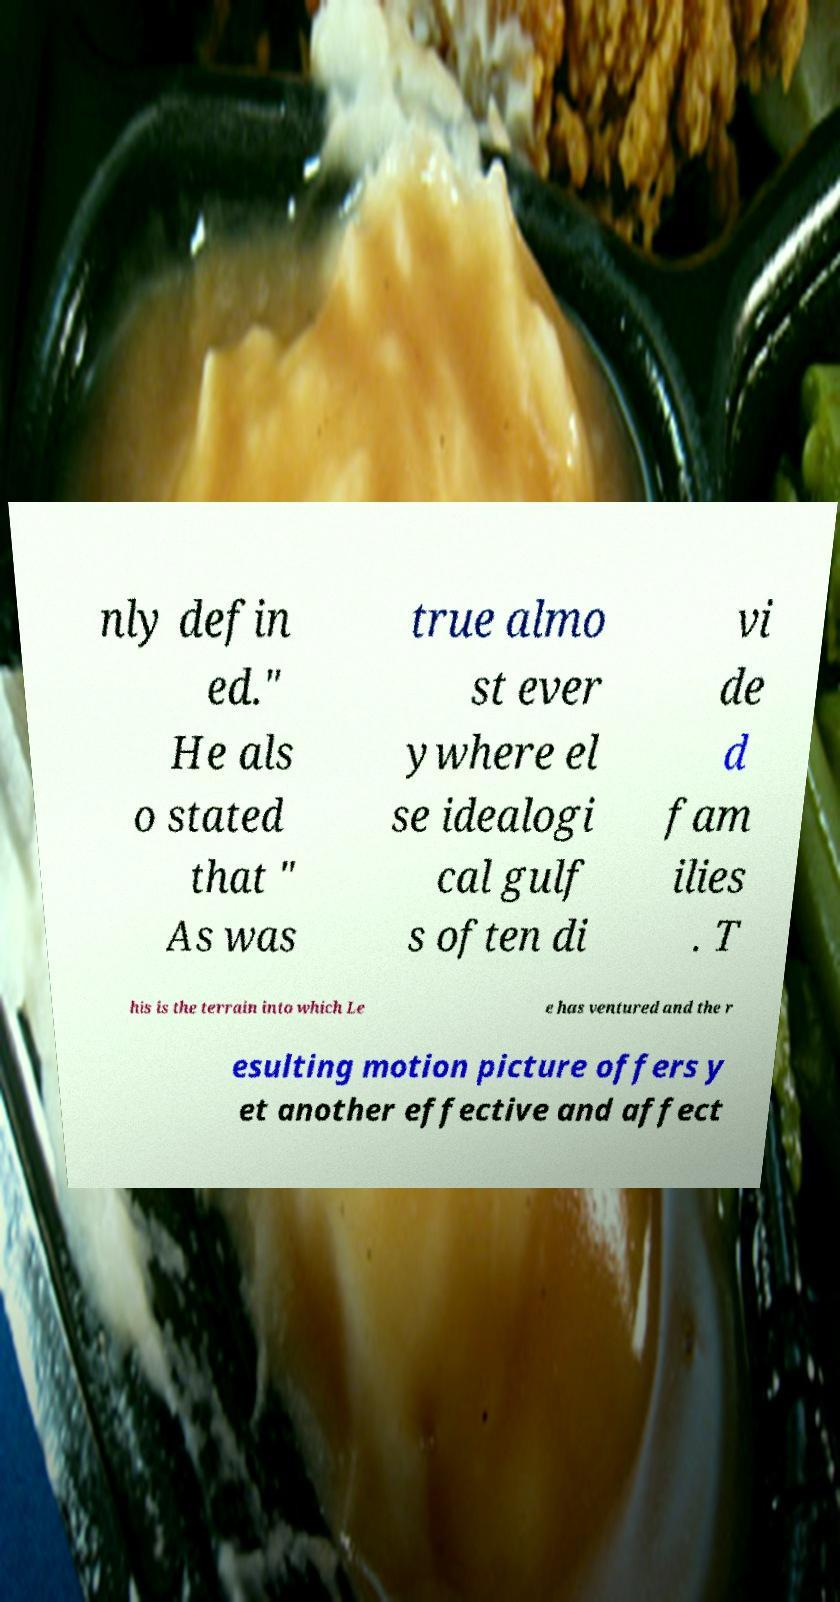What messages or text are displayed in this image? I need them in a readable, typed format. nly defin ed." He als o stated that " As was true almo st ever ywhere el se idealogi cal gulf s often di vi de d fam ilies . T his is the terrain into which Le e has ventured and the r esulting motion picture offers y et another effective and affect 